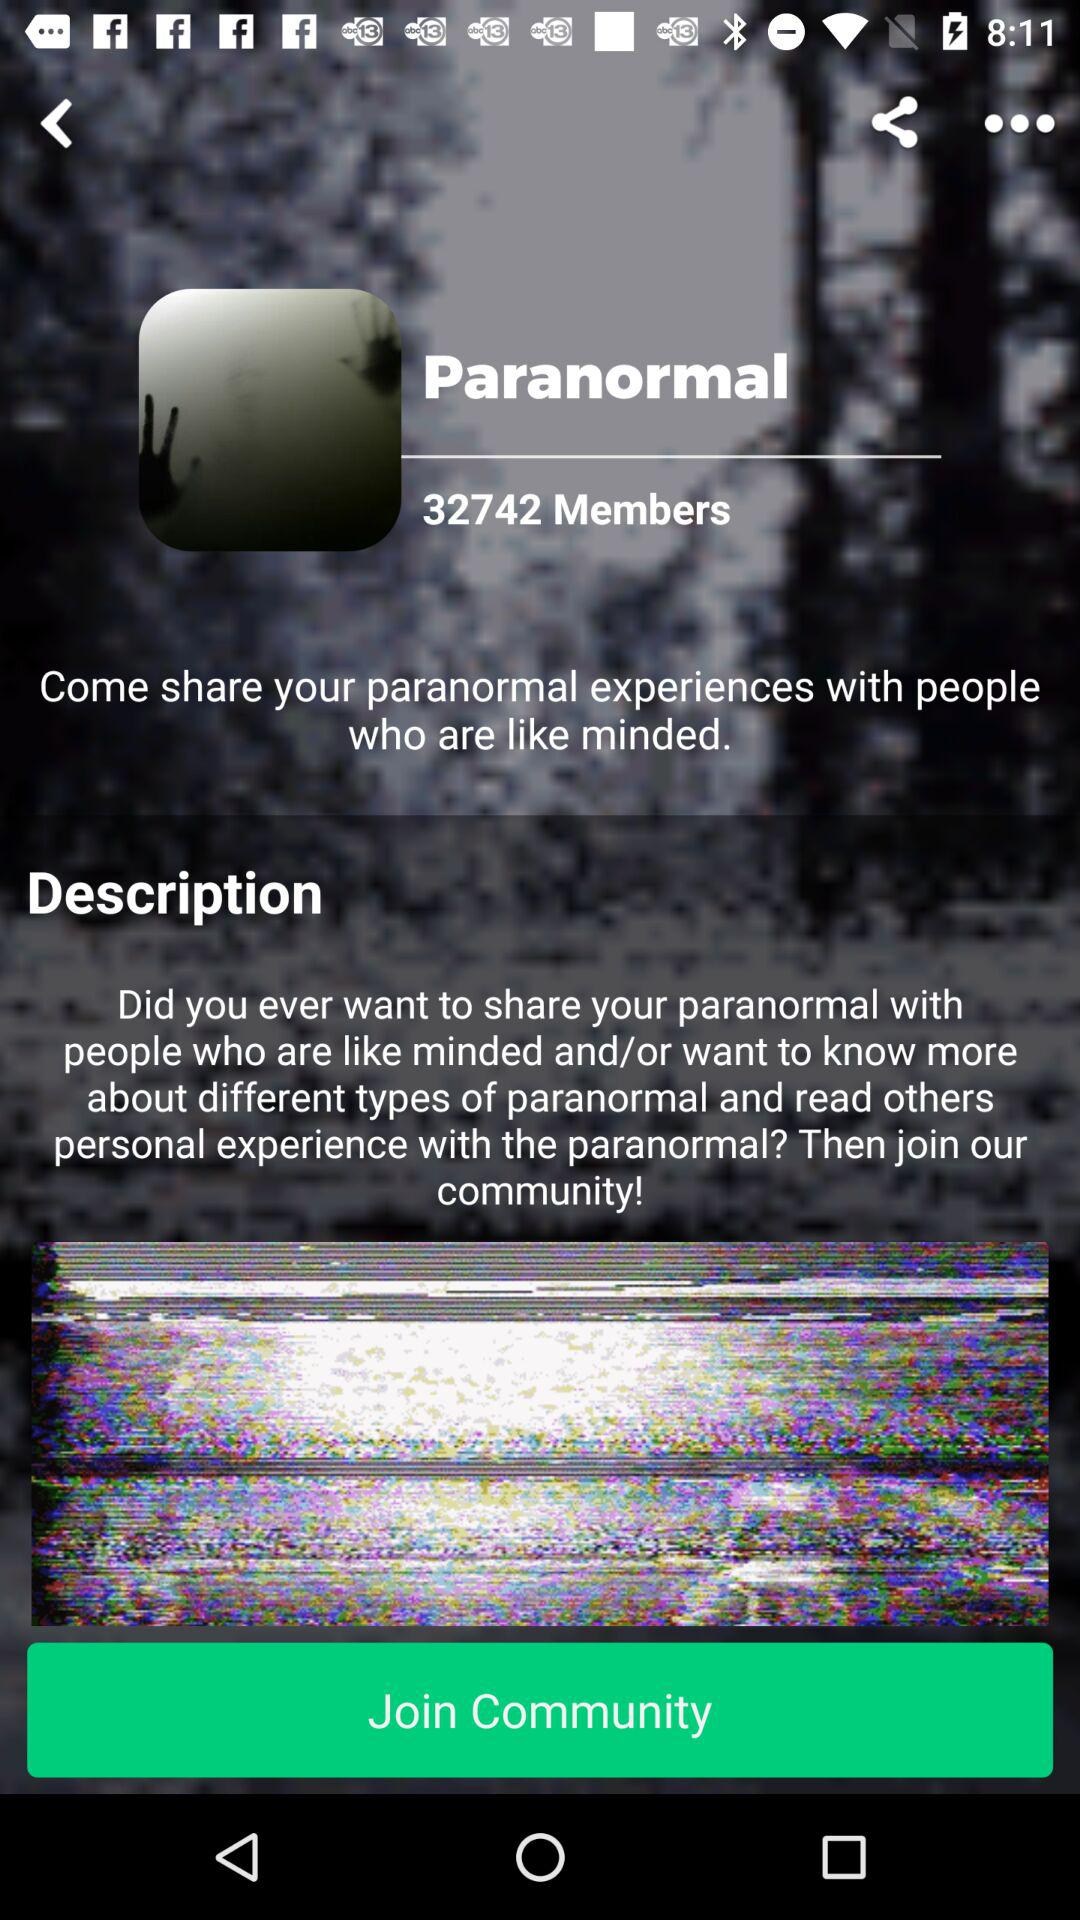With whom can I share my paranormal experiences? You can share your paranormal experiences with people who are like-minded. 